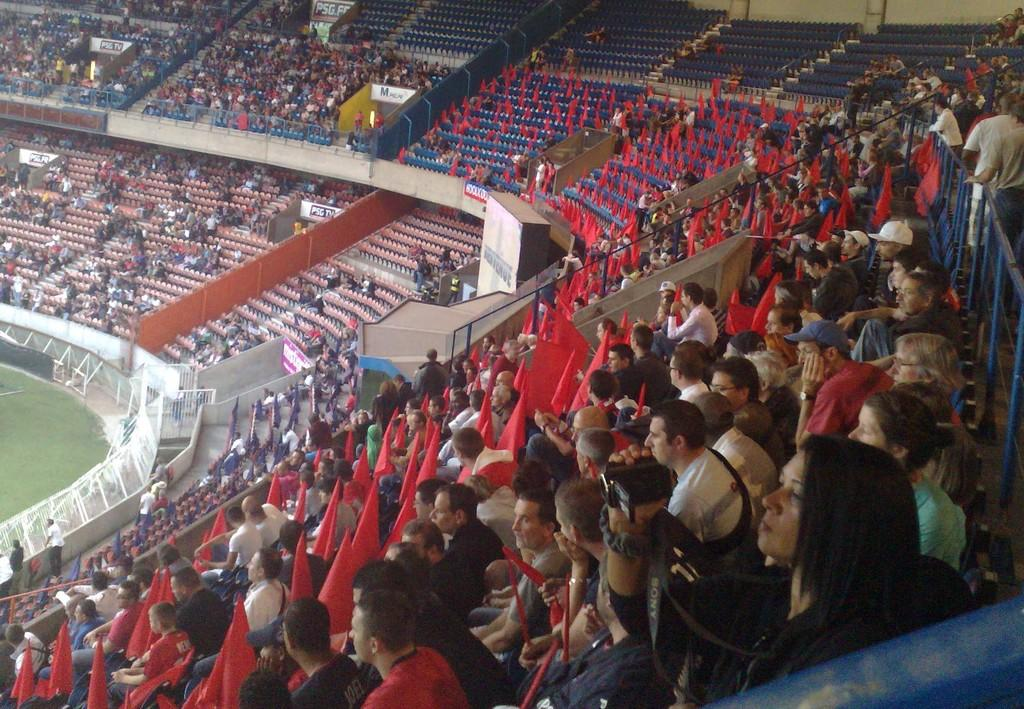What are the persons in the image doing? The persons in the image are sitting in a chair and holding flags. Can you describe the flags they are holding? Unfortunately, the facts provided do not give any details about the flags. What can be seen on the left side of the image? There is a ground visible on the left side of the image. What type of flock can be seen flying in the image? There is no flock visible in the image; it only shows persons sitting in a chair and holding flags. What is the skin condition of the persons in the image? The facts provided do not give any information about the skin condition of the persons in the image. 